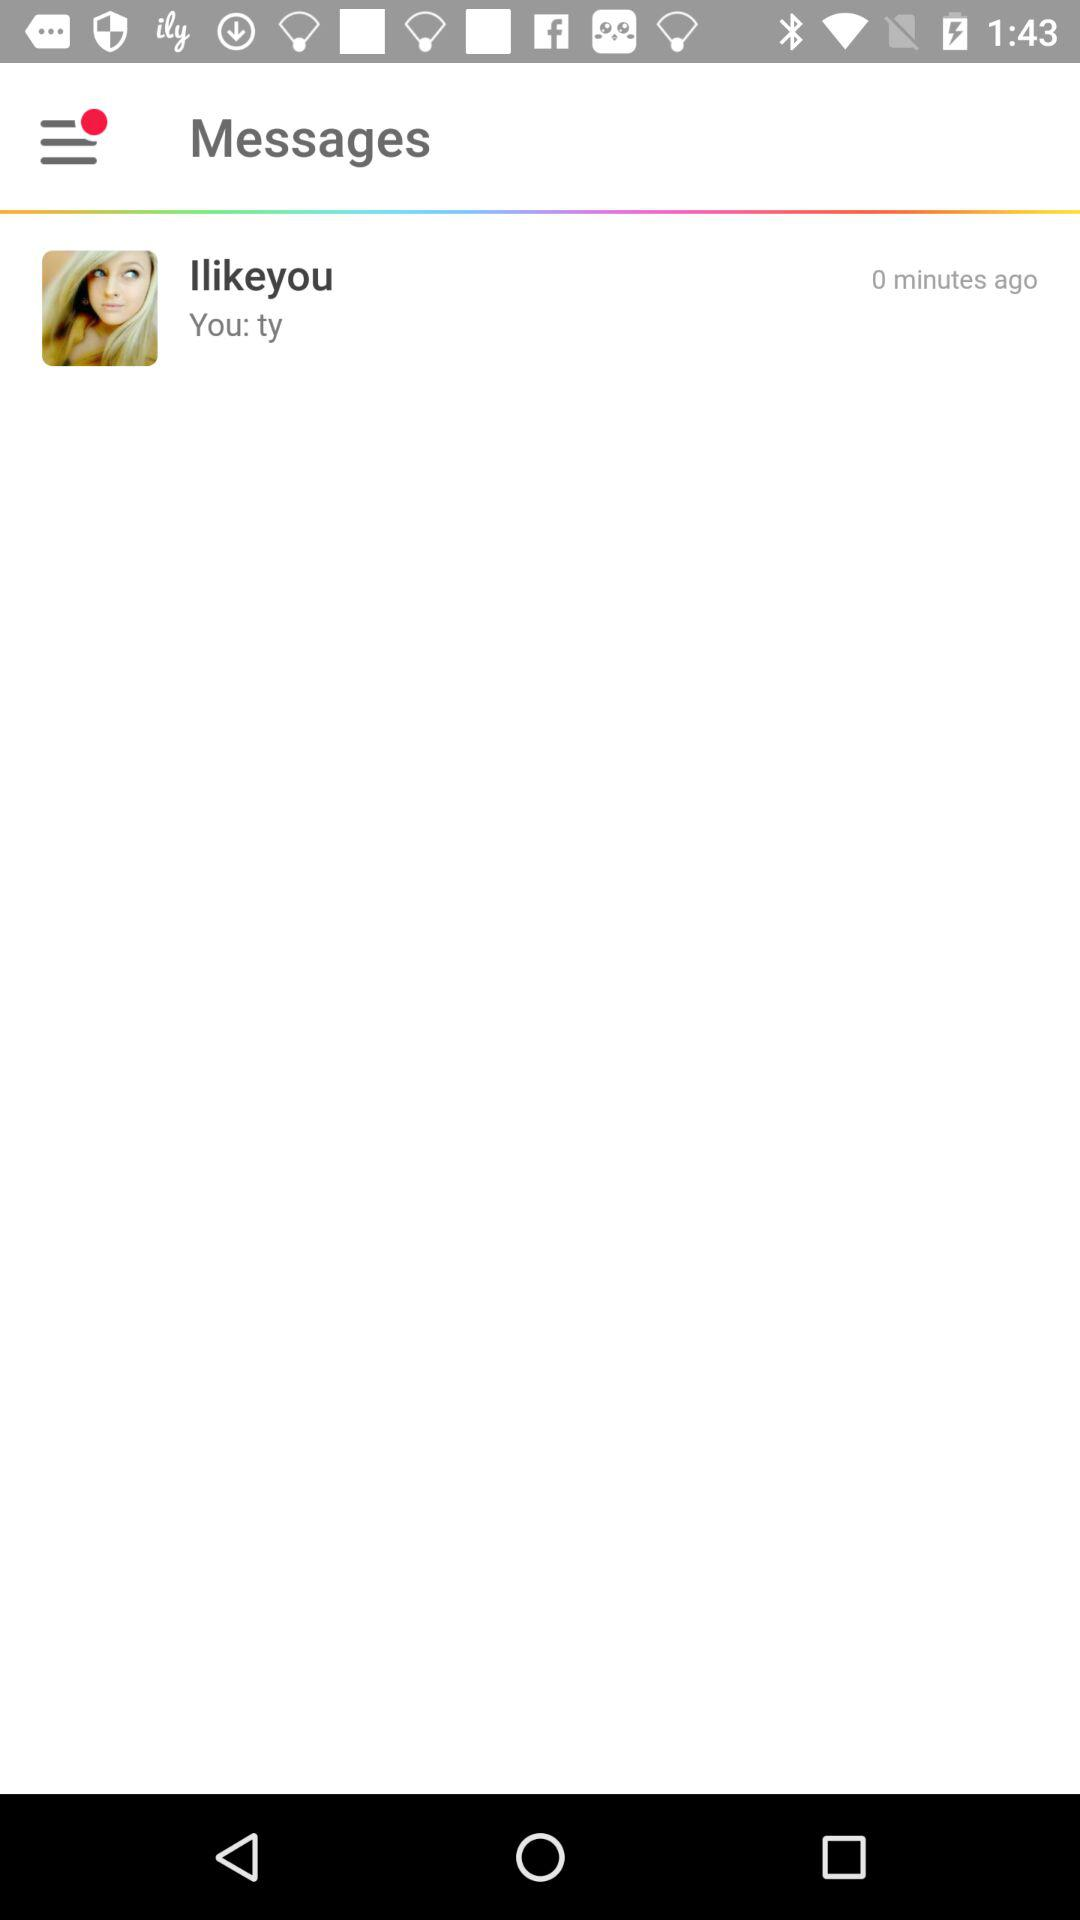To whom is the communication addressed? The communication is addressed to "Ilikeyou". 